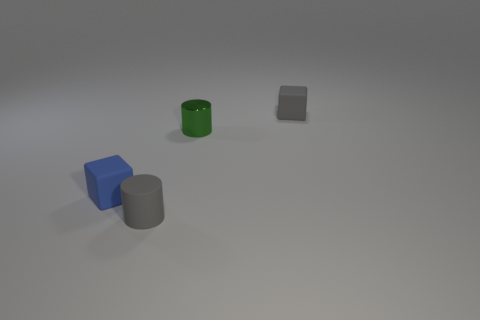How many green objects are tiny metal things or tiny matte cylinders?
Make the answer very short. 1. What number of cylinders are there?
Give a very brief answer. 2. There is a rubber cube in front of the small green metal cylinder; what size is it?
Keep it short and to the point. Small. Does the gray cube have the same size as the rubber cylinder?
Offer a very short reply. Yes. What number of objects are gray blocks or small rubber cylinders left of the tiny green shiny cylinder?
Ensure brevity in your answer.  2. What is the material of the small blue object?
Provide a short and direct response. Rubber. Is there any other thing that is the same color as the small shiny object?
Provide a succinct answer. No. Does the tiny metal thing have the same shape as the blue thing?
Keep it short and to the point. No. There is a cylinder in front of the blue matte object behind the cylinder that is on the left side of the green object; what size is it?
Give a very brief answer. Small. What number of other objects are the same material as the tiny gray block?
Offer a terse response. 2. 